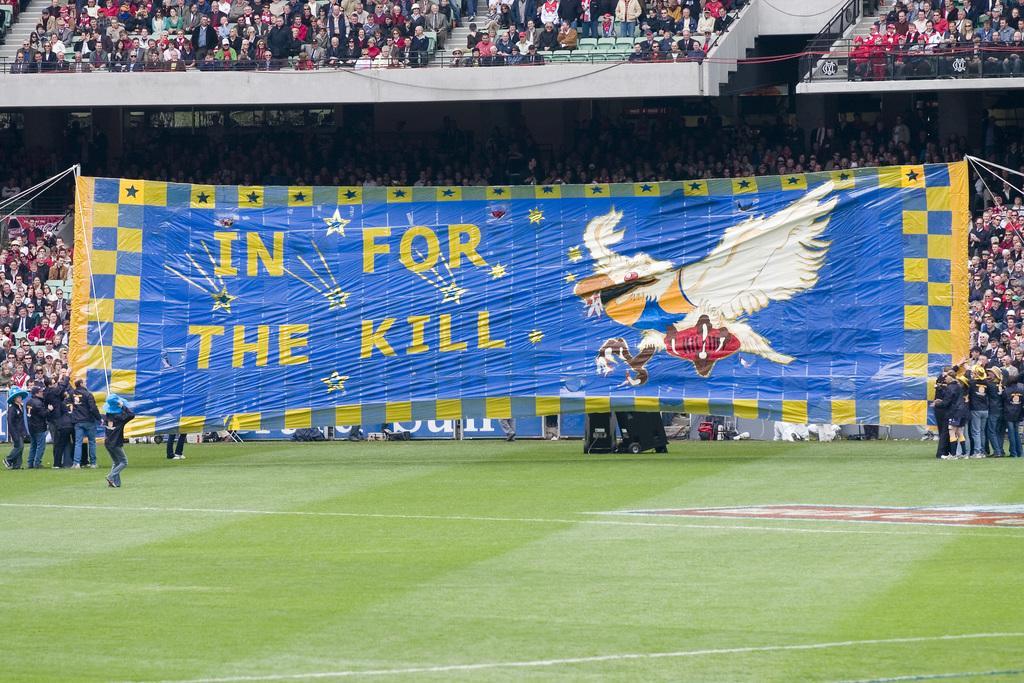Could you give a brief overview of what you see in this image? This picture might be taken in a stadium, in this picture in the center there is one board. On the board there is text and also there are a group, of people standing. And in the background there are some people sitting and there is a railing. At the bottom there is ground. 